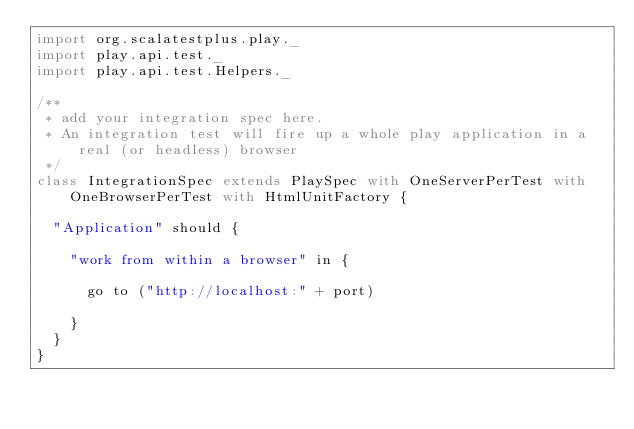Convert code to text. <code><loc_0><loc_0><loc_500><loc_500><_Scala_>import org.scalatestplus.play._
import play.api.test._
import play.api.test.Helpers._

/**
 * add your integration spec here.
 * An integration test will fire up a whole play application in a real (or headless) browser
 */
class IntegrationSpec extends PlaySpec with OneServerPerTest with OneBrowserPerTest with HtmlUnitFactory {

  "Application" should {

    "work from within a browser" in {

      go to ("http://localhost:" + port)

    }
  }
}
</code> 